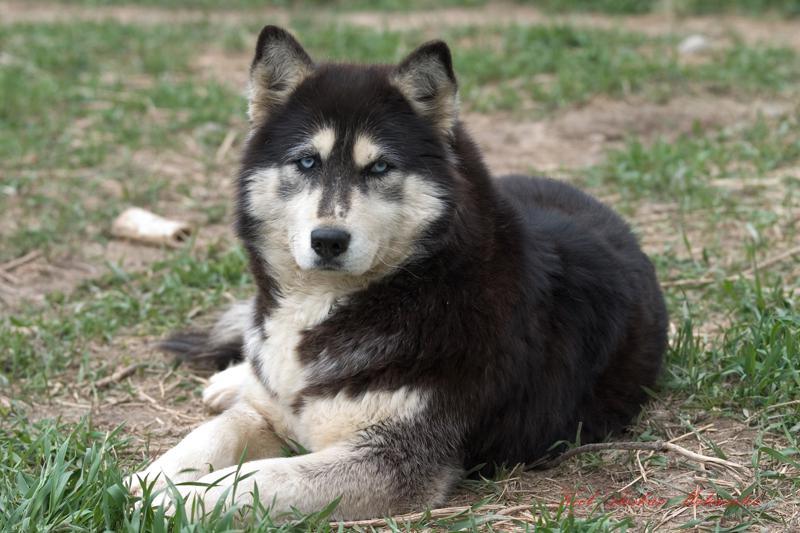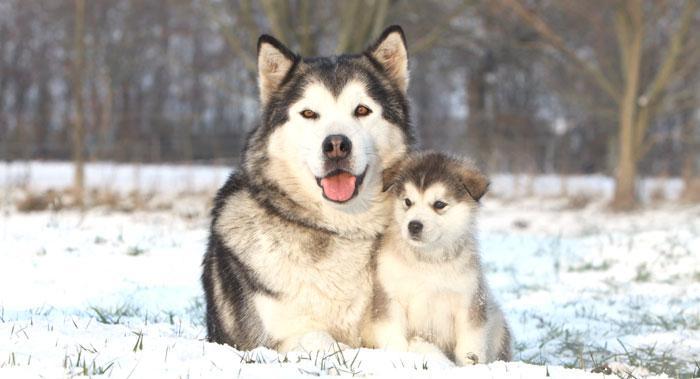The first image is the image on the left, the second image is the image on the right. Examine the images to the left and right. Is the description "A dog has its tongue out." accurate? Answer yes or no. Yes. The first image is the image on the left, the second image is the image on the right. Given the left and right images, does the statement "There are exactly two dogs in total." hold true? Answer yes or no. No. 